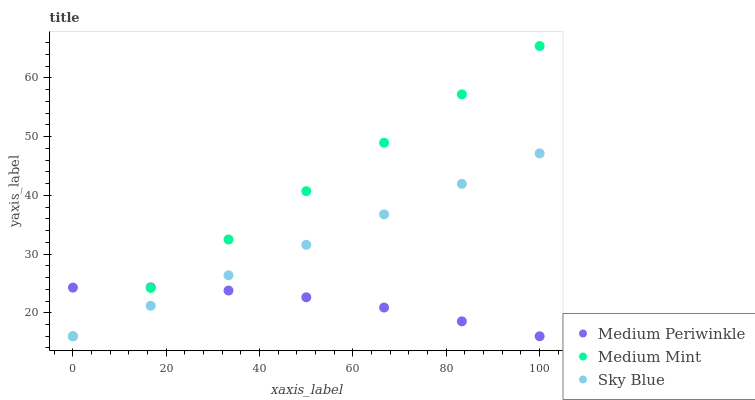Does Medium Periwinkle have the minimum area under the curve?
Answer yes or no. Yes. Does Medium Mint have the maximum area under the curve?
Answer yes or no. Yes. Does Sky Blue have the minimum area under the curve?
Answer yes or no. No. Does Sky Blue have the maximum area under the curve?
Answer yes or no. No. Is Medium Mint the smoothest?
Answer yes or no. Yes. Is Medium Periwinkle the roughest?
Answer yes or no. Yes. Is Medium Periwinkle the smoothest?
Answer yes or no. No. Is Sky Blue the roughest?
Answer yes or no. No. Does Medium Mint have the lowest value?
Answer yes or no. Yes. Does Medium Mint have the highest value?
Answer yes or no. Yes. Does Sky Blue have the highest value?
Answer yes or no. No. Does Medium Mint intersect Medium Periwinkle?
Answer yes or no. Yes. Is Medium Mint less than Medium Periwinkle?
Answer yes or no. No. Is Medium Mint greater than Medium Periwinkle?
Answer yes or no. No. 